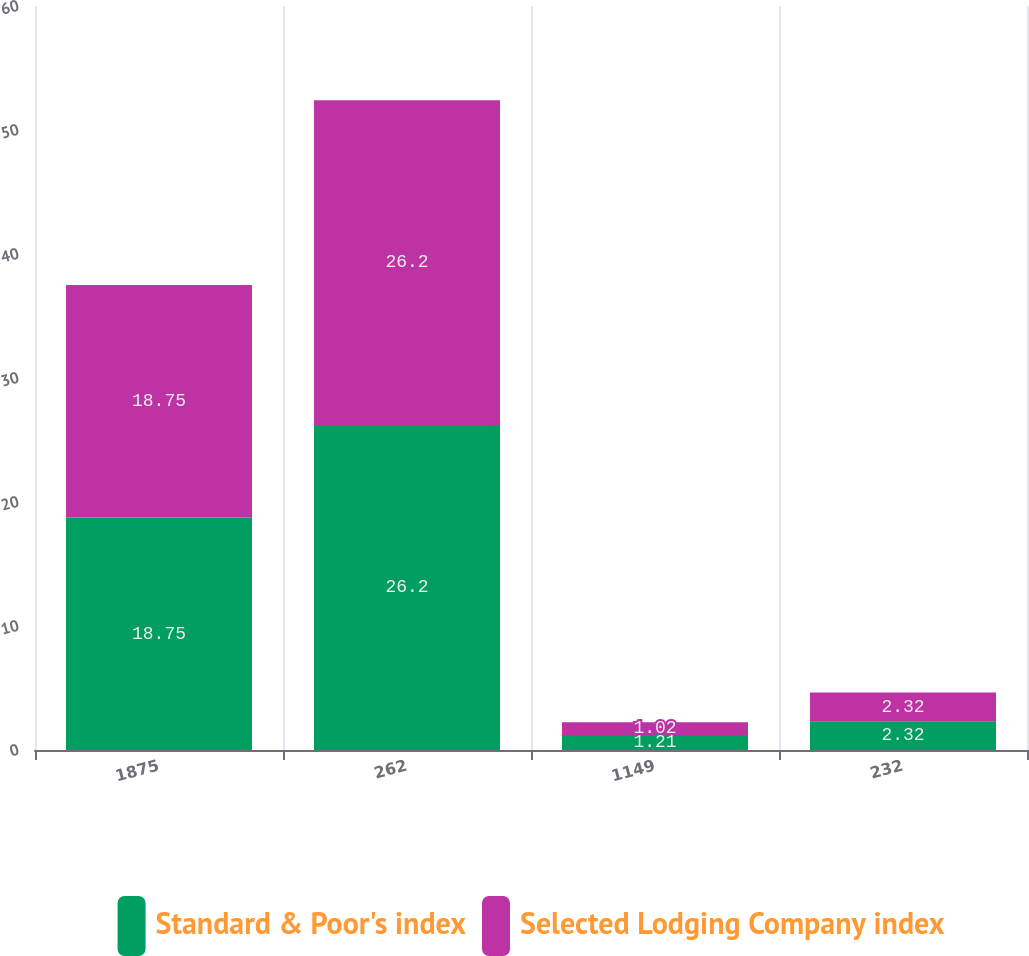<chart> <loc_0><loc_0><loc_500><loc_500><stacked_bar_chart><ecel><fcel>1875<fcel>262<fcel>1149<fcel>232<nl><fcel>Standard & Poor's index<fcel>18.75<fcel>26.2<fcel>1.21<fcel>2.32<nl><fcel>Selected Lodging Company index<fcel>18.75<fcel>26.2<fcel>1.02<fcel>2.32<nl></chart> 